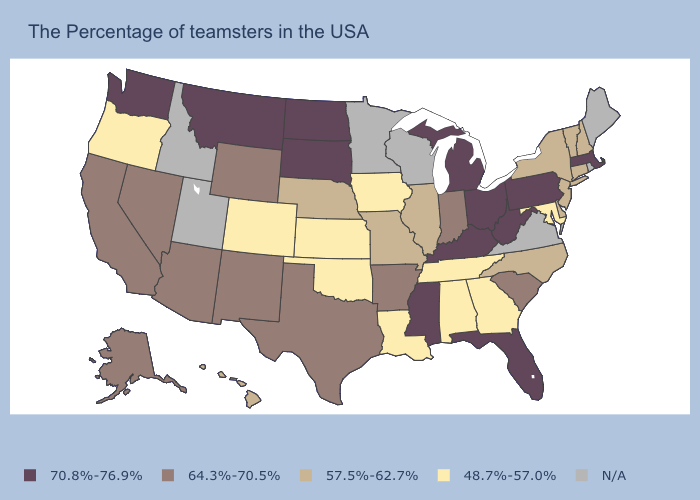What is the highest value in states that border Utah?
Short answer required. 64.3%-70.5%. Name the states that have a value in the range N/A?
Short answer required. Maine, Rhode Island, Virginia, Wisconsin, Minnesota, Utah, Idaho. Does the map have missing data?
Keep it brief. Yes. Name the states that have a value in the range N/A?
Write a very short answer. Maine, Rhode Island, Virginia, Wisconsin, Minnesota, Utah, Idaho. Among the states that border Connecticut , which have the lowest value?
Keep it brief. New York. What is the value of New Mexico?
Answer briefly. 64.3%-70.5%. Is the legend a continuous bar?
Quick response, please. No. Does West Virginia have the highest value in the South?
Write a very short answer. Yes. What is the value of Massachusetts?
Concise answer only. 70.8%-76.9%. Name the states that have a value in the range 48.7%-57.0%?
Write a very short answer. Maryland, Georgia, Alabama, Tennessee, Louisiana, Iowa, Kansas, Oklahoma, Colorado, Oregon. Name the states that have a value in the range 64.3%-70.5%?
Be succinct. South Carolina, Indiana, Arkansas, Texas, Wyoming, New Mexico, Arizona, Nevada, California, Alaska. Does South Dakota have the highest value in the USA?
Short answer required. Yes. How many symbols are there in the legend?
Concise answer only. 5. Name the states that have a value in the range N/A?
Short answer required. Maine, Rhode Island, Virginia, Wisconsin, Minnesota, Utah, Idaho. 